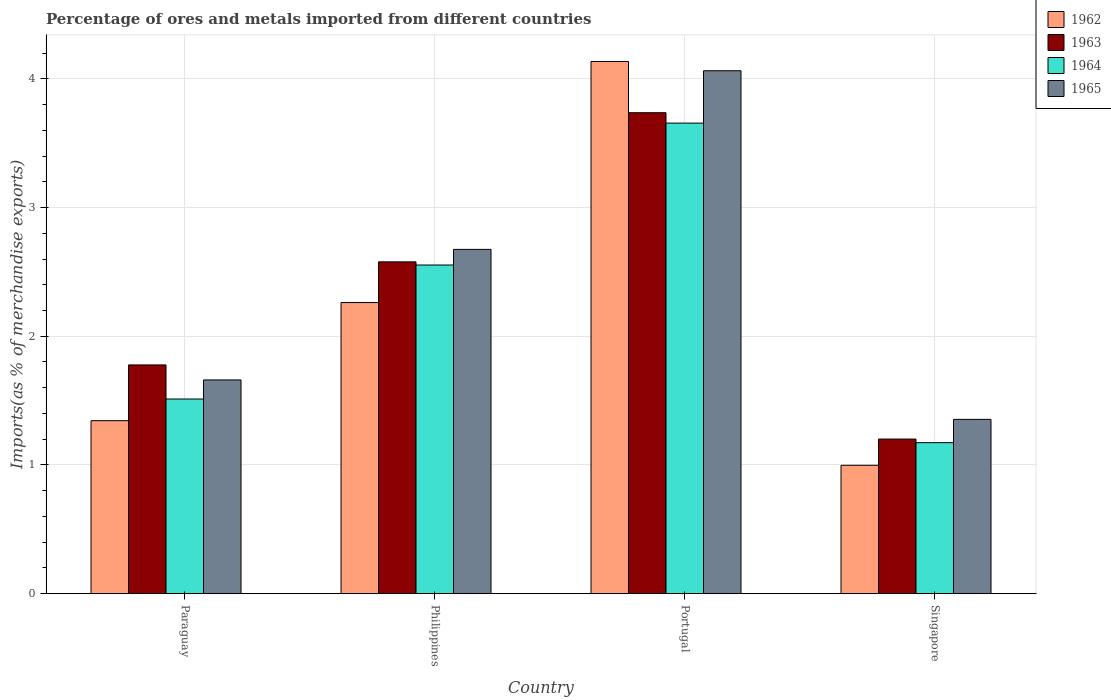How many groups of bars are there?
Make the answer very short. 4. How many bars are there on the 4th tick from the left?
Offer a terse response. 4. What is the label of the 1st group of bars from the left?
Give a very brief answer. Paraguay. In how many cases, is the number of bars for a given country not equal to the number of legend labels?
Give a very brief answer. 0. What is the percentage of imports to different countries in 1964 in Paraguay?
Offer a terse response. 1.51. Across all countries, what is the maximum percentage of imports to different countries in 1964?
Offer a very short reply. 3.66. Across all countries, what is the minimum percentage of imports to different countries in 1965?
Your answer should be compact. 1.35. In which country was the percentage of imports to different countries in 1964 minimum?
Ensure brevity in your answer.  Singapore. What is the total percentage of imports to different countries in 1964 in the graph?
Your answer should be compact. 8.89. What is the difference between the percentage of imports to different countries in 1963 in Paraguay and that in Portugal?
Ensure brevity in your answer.  -1.96. What is the difference between the percentage of imports to different countries in 1963 in Paraguay and the percentage of imports to different countries in 1965 in Portugal?
Give a very brief answer. -2.29. What is the average percentage of imports to different countries in 1964 per country?
Your response must be concise. 2.22. What is the difference between the percentage of imports to different countries of/in 1964 and percentage of imports to different countries of/in 1963 in Singapore?
Your answer should be very brief. -0.03. What is the ratio of the percentage of imports to different countries in 1962 in Paraguay to that in Philippines?
Offer a very short reply. 0.59. Is the difference between the percentage of imports to different countries in 1964 in Portugal and Singapore greater than the difference between the percentage of imports to different countries in 1963 in Portugal and Singapore?
Offer a terse response. No. What is the difference between the highest and the second highest percentage of imports to different countries in 1963?
Ensure brevity in your answer.  -0.8. What is the difference between the highest and the lowest percentage of imports to different countries in 1965?
Offer a terse response. 2.71. In how many countries, is the percentage of imports to different countries in 1964 greater than the average percentage of imports to different countries in 1964 taken over all countries?
Offer a very short reply. 2. Is the sum of the percentage of imports to different countries in 1963 in Paraguay and Singapore greater than the maximum percentage of imports to different countries in 1965 across all countries?
Make the answer very short. No. Is it the case that in every country, the sum of the percentage of imports to different countries in 1963 and percentage of imports to different countries in 1962 is greater than the sum of percentage of imports to different countries in 1964 and percentage of imports to different countries in 1965?
Offer a terse response. No. Are all the bars in the graph horizontal?
Offer a terse response. No. What is the difference between two consecutive major ticks on the Y-axis?
Your answer should be compact. 1. Are the values on the major ticks of Y-axis written in scientific E-notation?
Offer a terse response. No. Does the graph contain grids?
Ensure brevity in your answer.  Yes. Where does the legend appear in the graph?
Offer a very short reply. Top right. How are the legend labels stacked?
Provide a succinct answer. Vertical. What is the title of the graph?
Offer a terse response. Percentage of ores and metals imported from different countries. What is the label or title of the X-axis?
Make the answer very short. Country. What is the label or title of the Y-axis?
Your answer should be compact. Imports(as % of merchandise exports). What is the Imports(as % of merchandise exports) in 1962 in Paraguay?
Provide a short and direct response. 1.34. What is the Imports(as % of merchandise exports) in 1963 in Paraguay?
Offer a terse response. 1.78. What is the Imports(as % of merchandise exports) of 1964 in Paraguay?
Your answer should be compact. 1.51. What is the Imports(as % of merchandise exports) in 1965 in Paraguay?
Offer a terse response. 1.66. What is the Imports(as % of merchandise exports) in 1962 in Philippines?
Keep it short and to the point. 2.26. What is the Imports(as % of merchandise exports) in 1963 in Philippines?
Ensure brevity in your answer.  2.58. What is the Imports(as % of merchandise exports) in 1964 in Philippines?
Provide a short and direct response. 2.55. What is the Imports(as % of merchandise exports) in 1965 in Philippines?
Your answer should be compact. 2.67. What is the Imports(as % of merchandise exports) of 1962 in Portugal?
Your response must be concise. 4.13. What is the Imports(as % of merchandise exports) of 1963 in Portugal?
Your answer should be very brief. 3.74. What is the Imports(as % of merchandise exports) of 1964 in Portugal?
Offer a terse response. 3.66. What is the Imports(as % of merchandise exports) in 1965 in Portugal?
Provide a short and direct response. 4.06. What is the Imports(as % of merchandise exports) of 1962 in Singapore?
Provide a short and direct response. 1. What is the Imports(as % of merchandise exports) in 1963 in Singapore?
Offer a terse response. 1.2. What is the Imports(as % of merchandise exports) in 1964 in Singapore?
Your response must be concise. 1.17. What is the Imports(as % of merchandise exports) of 1965 in Singapore?
Your answer should be compact. 1.35. Across all countries, what is the maximum Imports(as % of merchandise exports) in 1962?
Offer a terse response. 4.13. Across all countries, what is the maximum Imports(as % of merchandise exports) of 1963?
Your answer should be compact. 3.74. Across all countries, what is the maximum Imports(as % of merchandise exports) in 1964?
Provide a short and direct response. 3.66. Across all countries, what is the maximum Imports(as % of merchandise exports) in 1965?
Offer a terse response. 4.06. Across all countries, what is the minimum Imports(as % of merchandise exports) of 1962?
Provide a short and direct response. 1. Across all countries, what is the minimum Imports(as % of merchandise exports) of 1963?
Offer a very short reply. 1.2. Across all countries, what is the minimum Imports(as % of merchandise exports) of 1964?
Provide a succinct answer. 1.17. Across all countries, what is the minimum Imports(as % of merchandise exports) of 1965?
Ensure brevity in your answer.  1.35. What is the total Imports(as % of merchandise exports) of 1962 in the graph?
Give a very brief answer. 8.74. What is the total Imports(as % of merchandise exports) of 1963 in the graph?
Your answer should be compact. 9.29. What is the total Imports(as % of merchandise exports) in 1964 in the graph?
Offer a very short reply. 8.89. What is the total Imports(as % of merchandise exports) of 1965 in the graph?
Keep it short and to the point. 9.75. What is the difference between the Imports(as % of merchandise exports) of 1962 in Paraguay and that in Philippines?
Provide a short and direct response. -0.92. What is the difference between the Imports(as % of merchandise exports) in 1963 in Paraguay and that in Philippines?
Offer a terse response. -0.8. What is the difference between the Imports(as % of merchandise exports) of 1964 in Paraguay and that in Philippines?
Make the answer very short. -1.04. What is the difference between the Imports(as % of merchandise exports) of 1965 in Paraguay and that in Philippines?
Give a very brief answer. -1.01. What is the difference between the Imports(as % of merchandise exports) of 1962 in Paraguay and that in Portugal?
Give a very brief answer. -2.79. What is the difference between the Imports(as % of merchandise exports) of 1963 in Paraguay and that in Portugal?
Ensure brevity in your answer.  -1.96. What is the difference between the Imports(as % of merchandise exports) of 1964 in Paraguay and that in Portugal?
Offer a terse response. -2.14. What is the difference between the Imports(as % of merchandise exports) in 1965 in Paraguay and that in Portugal?
Your response must be concise. -2.4. What is the difference between the Imports(as % of merchandise exports) of 1962 in Paraguay and that in Singapore?
Your response must be concise. 0.35. What is the difference between the Imports(as % of merchandise exports) of 1963 in Paraguay and that in Singapore?
Your answer should be very brief. 0.58. What is the difference between the Imports(as % of merchandise exports) in 1964 in Paraguay and that in Singapore?
Provide a short and direct response. 0.34. What is the difference between the Imports(as % of merchandise exports) in 1965 in Paraguay and that in Singapore?
Offer a terse response. 0.31. What is the difference between the Imports(as % of merchandise exports) in 1962 in Philippines and that in Portugal?
Your answer should be compact. -1.87. What is the difference between the Imports(as % of merchandise exports) of 1963 in Philippines and that in Portugal?
Ensure brevity in your answer.  -1.16. What is the difference between the Imports(as % of merchandise exports) of 1964 in Philippines and that in Portugal?
Offer a very short reply. -1.1. What is the difference between the Imports(as % of merchandise exports) in 1965 in Philippines and that in Portugal?
Ensure brevity in your answer.  -1.39. What is the difference between the Imports(as % of merchandise exports) of 1962 in Philippines and that in Singapore?
Offer a terse response. 1.26. What is the difference between the Imports(as % of merchandise exports) in 1963 in Philippines and that in Singapore?
Your response must be concise. 1.38. What is the difference between the Imports(as % of merchandise exports) in 1964 in Philippines and that in Singapore?
Provide a succinct answer. 1.38. What is the difference between the Imports(as % of merchandise exports) of 1965 in Philippines and that in Singapore?
Offer a very short reply. 1.32. What is the difference between the Imports(as % of merchandise exports) in 1962 in Portugal and that in Singapore?
Provide a succinct answer. 3.14. What is the difference between the Imports(as % of merchandise exports) in 1963 in Portugal and that in Singapore?
Provide a succinct answer. 2.54. What is the difference between the Imports(as % of merchandise exports) of 1964 in Portugal and that in Singapore?
Your answer should be compact. 2.48. What is the difference between the Imports(as % of merchandise exports) in 1965 in Portugal and that in Singapore?
Make the answer very short. 2.71. What is the difference between the Imports(as % of merchandise exports) in 1962 in Paraguay and the Imports(as % of merchandise exports) in 1963 in Philippines?
Provide a succinct answer. -1.23. What is the difference between the Imports(as % of merchandise exports) of 1962 in Paraguay and the Imports(as % of merchandise exports) of 1964 in Philippines?
Your answer should be compact. -1.21. What is the difference between the Imports(as % of merchandise exports) in 1962 in Paraguay and the Imports(as % of merchandise exports) in 1965 in Philippines?
Ensure brevity in your answer.  -1.33. What is the difference between the Imports(as % of merchandise exports) in 1963 in Paraguay and the Imports(as % of merchandise exports) in 1964 in Philippines?
Make the answer very short. -0.78. What is the difference between the Imports(as % of merchandise exports) in 1963 in Paraguay and the Imports(as % of merchandise exports) in 1965 in Philippines?
Offer a terse response. -0.9. What is the difference between the Imports(as % of merchandise exports) of 1964 in Paraguay and the Imports(as % of merchandise exports) of 1965 in Philippines?
Provide a short and direct response. -1.16. What is the difference between the Imports(as % of merchandise exports) of 1962 in Paraguay and the Imports(as % of merchandise exports) of 1963 in Portugal?
Your response must be concise. -2.39. What is the difference between the Imports(as % of merchandise exports) of 1962 in Paraguay and the Imports(as % of merchandise exports) of 1964 in Portugal?
Provide a short and direct response. -2.31. What is the difference between the Imports(as % of merchandise exports) in 1962 in Paraguay and the Imports(as % of merchandise exports) in 1965 in Portugal?
Your answer should be compact. -2.72. What is the difference between the Imports(as % of merchandise exports) of 1963 in Paraguay and the Imports(as % of merchandise exports) of 1964 in Portugal?
Provide a short and direct response. -1.88. What is the difference between the Imports(as % of merchandise exports) in 1963 in Paraguay and the Imports(as % of merchandise exports) in 1965 in Portugal?
Give a very brief answer. -2.29. What is the difference between the Imports(as % of merchandise exports) in 1964 in Paraguay and the Imports(as % of merchandise exports) in 1965 in Portugal?
Offer a very short reply. -2.55. What is the difference between the Imports(as % of merchandise exports) in 1962 in Paraguay and the Imports(as % of merchandise exports) in 1963 in Singapore?
Offer a terse response. 0.14. What is the difference between the Imports(as % of merchandise exports) in 1962 in Paraguay and the Imports(as % of merchandise exports) in 1964 in Singapore?
Provide a succinct answer. 0.17. What is the difference between the Imports(as % of merchandise exports) of 1962 in Paraguay and the Imports(as % of merchandise exports) of 1965 in Singapore?
Keep it short and to the point. -0.01. What is the difference between the Imports(as % of merchandise exports) in 1963 in Paraguay and the Imports(as % of merchandise exports) in 1964 in Singapore?
Keep it short and to the point. 0.6. What is the difference between the Imports(as % of merchandise exports) in 1963 in Paraguay and the Imports(as % of merchandise exports) in 1965 in Singapore?
Offer a very short reply. 0.42. What is the difference between the Imports(as % of merchandise exports) in 1964 in Paraguay and the Imports(as % of merchandise exports) in 1965 in Singapore?
Provide a short and direct response. 0.16. What is the difference between the Imports(as % of merchandise exports) in 1962 in Philippines and the Imports(as % of merchandise exports) in 1963 in Portugal?
Keep it short and to the point. -1.47. What is the difference between the Imports(as % of merchandise exports) of 1962 in Philippines and the Imports(as % of merchandise exports) of 1964 in Portugal?
Offer a very short reply. -1.39. What is the difference between the Imports(as % of merchandise exports) of 1962 in Philippines and the Imports(as % of merchandise exports) of 1965 in Portugal?
Offer a very short reply. -1.8. What is the difference between the Imports(as % of merchandise exports) of 1963 in Philippines and the Imports(as % of merchandise exports) of 1964 in Portugal?
Ensure brevity in your answer.  -1.08. What is the difference between the Imports(as % of merchandise exports) of 1963 in Philippines and the Imports(as % of merchandise exports) of 1965 in Portugal?
Give a very brief answer. -1.48. What is the difference between the Imports(as % of merchandise exports) of 1964 in Philippines and the Imports(as % of merchandise exports) of 1965 in Portugal?
Ensure brevity in your answer.  -1.51. What is the difference between the Imports(as % of merchandise exports) in 1962 in Philippines and the Imports(as % of merchandise exports) in 1963 in Singapore?
Your response must be concise. 1.06. What is the difference between the Imports(as % of merchandise exports) of 1962 in Philippines and the Imports(as % of merchandise exports) of 1964 in Singapore?
Provide a short and direct response. 1.09. What is the difference between the Imports(as % of merchandise exports) in 1962 in Philippines and the Imports(as % of merchandise exports) in 1965 in Singapore?
Your answer should be very brief. 0.91. What is the difference between the Imports(as % of merchandise exports) in 1963 in Philippines and the Imports(as % of merchandise exports) in 1964 in Singapore?
Your answer should be very brief. 1.4. What is the difference between the Imports(as % of merchandise exports) of 1963 in Philippines and the Imports(as % of merchandise exports) of 1965 in Singapore?
Keep it short and to the point. 1.22. What is the difference between the Imports(as % of merchandise exports) in 1964 in Philippines and the Imports(as % of merchandise exports) in 1965 in Singapore?
Offer a very short reply. 1.2. What is the difference between the Imports(as % of merchandise exports) in 1962 in Portugal and the Imports(as % of merchandise exports) in 1963 in Singapore?
Your answer should be very brief. 2.93. What is the difference between the Imports(as % of merchandise exports) of 1962 in Portugal and the Imports(as % of merchandise exports) of 1964 in Singapore?
Provide a succinct answer. 2.96. What is the difference between the Imports(as % of merchandise exports) in 1962 in Portugal and the Imports(as % of merchandise exports) in 1965 in Singapore?
Your answer should be compact. 2.78. What is the difference between the Imports(as % of merchandise exports) in 1963 in Portugal and the Imports(as % of merchandise exports) in 1964 in Singapore?
Your answer should be compact. 2.56. What is the difference between the Imports(as % of merchandise exports) in 1963 in Portugal and the Imports(as % of merchandise exports) in 1965 in Singapore?
Ensure brevity in your answer.  2.38. What is the difference between the Imports(as % of merchandise exports) in 1964 in Portugal and the Imports(as % of merchandise exports) in 1965 in Singapore?
Make the answer very short. 2.3. What is the average Imports(as % of merchandise exports) in 1962 per country?
Provide a short and direct response. 2.18. What is the average Imports(as % of merchandise exports) of 1963 per country?
Provide a short and direct response. 2.32. What is the average Imports(as % of merchandise exports) of 1964 per country?
Keep it short and to the point. 2.22. What is the average Imports(as % of merchandise exports) of 1965 per country?
Keep it short and to the point. 2.44. What is the difference between the Imports(as % of merchandise exports) of 1962 and Imports(as % of merchandise exports) of 1963 in Paraguay?
Provide a succinct answer. -0.43. What is the difference between the Imports(as % of merchandise exports) of 1962 and Imports(as % of merchandise exports) of 1964 in Paraguay?
Offer a very short reply. -0.17. What is the difference between the Imports(as % of merchandise exports) of 1962 and Imports(as % of merchandise exports) of 1965 in Paraguay?
Your answer should be very brief. -0.32. What is the difference between the Imports(as % of merchandise exports) in 1963 and Imports(as % of merchandise exports) in 1964 in Paraguay?
Provide a short and direct response. 0.26. What is the difference between the Imports(as % of merchandise exports) in 1963 and Imports(as % of merchandise exports) in 1965 in Paraguay?
Give a very brief answer. 0.12. What is the difference between the Imports(as % of merchandise exports) in 1964 and Imports(as % of merchandise exports) in 1965 in Paraguay?
Provide a short and direct response. -0.15. What is the difference between the Imports(as % of merchandise exports) of 1962 and Imports(as % of merchandise exports) of 1963 in Philippines?
Your answer should be compact. -0.32. What is the difference between the Imports(as % of merchandise exports) of 1962 and Imports(as % of merchandise exports) of 1964 in Philippines?
Make the answer very short. -0.29. What is the difference between the Imports(as % of merchandise exports) in 1962 and Imports(as % of merchandise exports) in 1965 in Philippines?
Your response must be concise. -0.41. What is the difference between the Imports(as % of merchandise exports) in 1963 and Imports(as % of merchandise exports) in 1964 in Philippines?
Ensure brevity in your answer.  0.02. What is the difference between the Imports(as % of merchandise exports) in 1963 and Imports(as % of merchandise exports) in 1965 in Philippines?
Your answer should be compact. -0.1. What is the difference between the Imports(as % of merchandise exports) in 1964 and Imports(as % of merchandise exports) in 1965 in Philippines?
Your answer should be compact. -0.12. What is the difference between the Imports(as % of merchandise exports) of 1962 and Imports(as % of merchandise exports) of 1963 in Portugal?
Make the answer very short. 0.4. What is the difference between the Imports(as % of merchandise exports) of 1962 and Imports(as % of merchandise exports) of 1964 in Portugal?
Keep it short and to the point. 0.48. What is the difference between the Imports(as % of merchandise exports) in 1962 and Imports(as % of merchandise exports) in 1965 in Portugal?
Make the answer very short. 0.07. What is the difference between the Imports(as % of merchandise exports) of 1963 and Imports(as % of merchandise exports) of 1964 in Portugal?
Your answer should be compact. 0.08. What is the difference between the Imports(as % of merchandise exports) in 1963 and Imports(as % of merchandise exports) in 1965 in Portugal?
Ensure brevity in your answer.  -0.33. What is the difference between the Imports(as % of merchandise exports) of 1964 and Imports(as % of merchandise exports) of 1965 in Portugal?
Keep it short and to the point. -0.41. What is the difference between the Imports(as % of merchandise exports) of 1962 and Imports(as % of merchandise exports) of 1963 in Singapore?
Ensure brevity in your answer.  -0.2. What is the difference between the Imports(as % of merchandise exports) in 1962 and Imports(as % of merchandise exports) in 1964 in Singapore?
Ensure brevity in your answer.  -0.18. What is the difference between the Imports(as % of merchandise exports) in 1962 and Imports(as % of merchandise exports) in 1965 in Singapore?
Ensure brevity in your answer.  -0.36. What is the difference between the Imports(as % of merchandise exports) in 1963 and Imports(as % of merchandise exports) in 1964 in Singapore?
Offer a very short reply. 0.03. What is the difference between the Imports(as % of merchandise exports) of 1963 and Imports(as % of merchandise exports) of 1965 in Singapore?
Give a very brief answer. -0.15. What is the difference between the Imports(as % of merchandise exports) in 1964 and Imports(as % of merchandise exports) in 1965 in Singapore?
Your answer should be compact. -0.18. What is the ratio of the Imports(as % of merchandise exports) of 1962 in Paraguay to that in Philippines?
Keep it short and to the point. 0.59. What is the ratio of the Imports(as % of merchandise exports) in 1963 in Paraguay to that in Philippines?
Provide a short and direct response. 0.69. What is the ratio of the Imports(as % of merchandise exports) of 1964 in Paraguay to that in Philippines?
Your answer should be compact. 0.59. What is the ratio of the Imports(as % of merchandise exports) of 1965 in Paraguay to that in Philippines?
Provide a short and direct response. 0.62. What is the ratio of the Imports(as % of merchandise exports) in 1962 in Paraguay to that in Portugal?
Provide a short and direct response. 0.33. What is the ratio of the Imports(as % of merchandise exports) in 1963 in Paraguay to that in Portugal?
Your answer should be compact. 0.48. What is the ratio of the Imports(as % of merchandise exports) of 1964 in Paraguay to that in Portugal?
Offer a very short reply. 0.41. What is the ratio of the Imports(as % of merchandise exports) in 1965 in Paraguay to that in Portugal?
Give a very brief answer. 0.41. What is the ratio of the Imports(as % of merchandise exports) of 1962 in Paraguay to that in Singapore?
Your answer should be very brief. 1.35. What is the ratio of the Imports(as % of merchandise exports) of 1963 in Paraguay to that in Singapore?
Offer a very short reply. 1.48. What is the ratio of the Imports(as % of merchandise exports) of 1964 in Paraguay to that in Singapore?
Make the answer very short. 1.29. What is the ratio of the Imports(as % of merchandise exports) in 1965 in Paraguay to that in Singapore?
Your answer should be compact. 1.23. What is the ratio of the Imports(as % of merchandise exports) in 1962 in Philippines to that in Portugal?
Make the answer very short. 0.55. What is the ratio of the Imports(as % of merchandise exports) in 1963 in Philippines to that in Portugal?
Your response must be concise. 0.69. What is the ratio of the Imports(as % of merchandise exports) in 1964 in Philippines to that in Portugal?
Ensure brevity in your answer.  0.7. What is the ratio of the Imports(as % of merchandise exports) of 1965 in Philippines to that in Portugal?
Offer a very short reply. 0.66. What is the ratio of the Imports(as % of merchandise exports) of 1962 in Philippines to that in Singapore?
Your answer should be very brief. 2.27. What is the ratio of the Imports(as % of merchandise exports) of 1963 in Philippines to that in Singapore?
Provide a succinct answer. 2.15. What is the ratio of the Imports(as % of merchandise exports) in 1964 in Philippines to that in Singapore?
Provide a short and direct response. 2.18. What is the ratio of the Imports(as % of merchandise exports) of 1965 in Philippines to that in Singapore?
Your response must be concise. 1.98. What is the ratio of the Imports(as % of merchandise exports) of 1962 in Portugal to that in Singapore?
Ensure brevity in your answer.  4.15. What is the ratio of the Imports(as % of merchandise exports) in 1963 in Portugal to that in Singapore?
Provide a succinct answer. 3.11. What is the ratio of the Imports(as % of merchandise exports) of 1964 in Portugal to that in Singapore?
Ensure brevity in your answer.  3.12. What is the ratio of the Imports(as % of merchandise exports) of 1965 in Portugal to that in Singapore?
Keep it short and to the point. 3. What is the difference between the highest and the second highest Imports(as % of merchandise exports) of 1962?
Provide a succinct answer. 1.87. What is the difference between the highest and the second highest Imports(as % of merchandise exports) in 1963?
Keep it short and to the point. 1.16. What is the difference between the highest and the second highest Imports(as % of merchandise exports) in 1964?
Your answer should be compact. 1.1. What is the difference between the highest and the second highest Imports(as % of merchandise exports) in 1965?
Keep it short and to the point. 1.39. What is the difference between the highest and the lowest Imports(as % of merchandise exports) of 1962?
Your answer should be very brief. 3.14. What is the difference between the highest and the lowest Imports(as % of merchandise exports) in 1963?
Make the answer very short. 2.54. What is the difference between the highest and the lowest Imports(as % of merchandise exports) of 1964?
Your answer should be compact. 2.48. What is the difference between the highest and the lowest Imports(as % of merchandise exports) in 1965?
Ensure brevity in your answer.  2.71. 